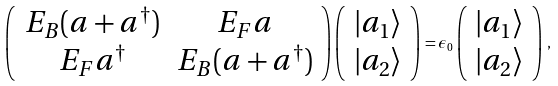<formula> <loc_0><loc_0><loc_500><loc_500>\left ( \begin{array} { c c } E _ { B } ( a + a ^ { \dag } ) & E _ { F } a \\ E _ { F } a ^ { \dag } & E _ { B } ( a + a ^ { \dag } ) \end{array} \right ) \left ( \begin{array} { c } | a _ { 1 } \rangle \\ | a _ { 2 } \rangle \end{array} \right ) = \epsilon _ { 0 } \left ( \begin{array} { c } | a _ { 1 } \rangle \\ | a _ { 2 } \rangle \end{array} \right ) \, ,</formula> 